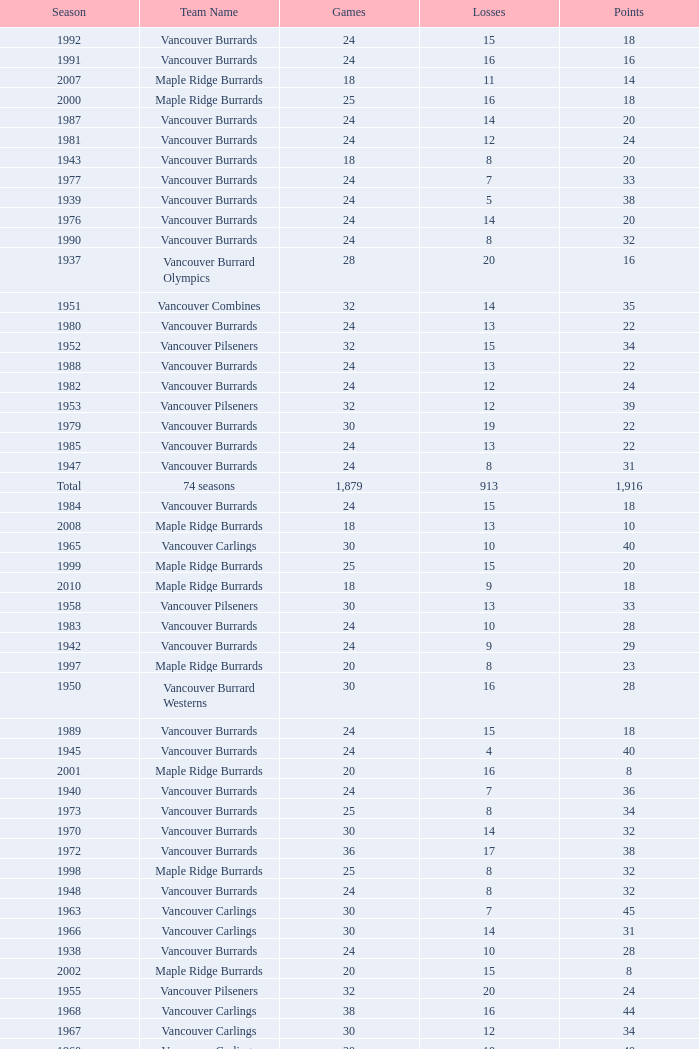What's the lowest number of points with fewer than 8 losses and fewer than 24 games for the vancouver burrards? 18.0. Write the full table. {'header': ['Season', 'Team Name', 'Games', 'Losses', 'Points'], 'rows': [['1992', 'Vancouver Burrards', '24', '15', '18'], ['1991', 'Vancouver Burrards', '24', '16', '16'], ['2007', 'Maple Ridge Burrards', '18', '11', '14'], ['2000', 'Maple Ridge Burrards', '25', '16', '18'], ['1987', 'Vancouver Burrards', '24', '14', '20'], ['1981', 'Vancouver Burrards', '24', '12', '24'], ['1943', 'Vancouver Burrards', '18', '8', '20'], ['1977', 'Vancouver Burrards', '24', '7', '33'], ['1939', 'Vancouver Burrards', '24', '5', '38'], ['1976', 'Vancouver Burrards', '24', '14', '20'], ['1990', 'Vancouver Burrards', '24', '8', '32'], ['1937', 'Vancouver Burrard Olympics', '28', '20', '16'], ['1951', 'Vancouver Combines', '32', '14', '35'], ['1980', 'Vancouver Burrards', '24', '13', '22'], ['1952', 'Vancouver Pilseners', '32', '15', '34'], ['1988', 'Vancouver Burrards', '24', '13', '22'], ['1982', 'Vancouver Burrards', '24', '12', '24'], ['1953', 'Vancouver Pilseners', '32', '12', '39'], ['1979', 'Vancouver Burrards', '30', '19', '22'], ['1985', 'Vancouver Burrards', '24', '13', '22'], ['1947', 'Vancouver Burrards', '24', '8', '31'], ['Total', '74 seasons', '1,879', '913', '1,916'], ['1984', 'Vancouver Burrards', '24', '15', '18'], ['2008', 'Maple Ridge Burrards', '18', '13', '10'], ['1965', 'Vancouver Carlings', '30', '10', '40'], ['1999', 'Maple Ridge Burrards', '25', '15', '20'], ['2010', 'Maple Ridge Burrards', '18', '9', '18'], ['1958', 'Vancouver Pilseners', '30', '13', '33'], ['1983', 'Vancouver Burrards', '24', '10', '28'], ['1942', 'Vancouver Burrards', '24', '9', '29'], ['1997', 'Maple Ridge Burrards', '20', '8', '23'], ['1950', 'Vancouver Burrard Westerns', '30', '16', '28'], ['1989', 'Vancouver Burrards', '24', '15', '18'], ['1945', 'Vancouver Burrards', '24', '4', '40'], ['2001', 'Maple Ridge Burrards', '20', '16', '8'], ['1940', 'Vancouver Burrards', '24', '7', '36'], ['1973', 'Vancouver Burrards', '25', '8', '34'], ['1970', 'Vancouver Burrards', '30', '14', '32'], ['1972', 'Vancouver Burrards', '36', '17', '38'], ['1998', 'Maple Ridge Burrards', '25', '8', '32'], ['1948', 'Vancouver Burrards', '24', '8', '32'], ['1963', 'Vancouver Carlings', '30', '7', '45'], ['1966', 'Vancouver Carlings', '30', '14', '31'], ['1938', 'Vancouver Burrards', '24', '10', '28'], ['2002', 'Maple Ridge Burrards', '20', '15', '8'], ['1955', 'Vancouver Pilseners', '32', '20', '24'], ['1968', 'Vancouver Carlings', '38', '16', '44'], ['1967', 'Vancouver Carlings', '30', '12', '34'], ['1960', 'Vancouver Carlings', '30', '10', '40'], ['1994', 'Surrey Burrards', '20', '12', '16'], ['2009', 'Maple Ridge Burrards', '18', '11', '14'], ['2006', 'Maple Ridge Burrards', '18', '11', '14'], ['1964', 'Vancouver Carlings', '32', '9', '46'], ['1961', 'Vancouver Carlings', '30', '9', '40'], ['1956', 'Vancouver Pilseners', '30', '13', '33'], ['1978', 'Vancouver Burrards', '24', '13', '22'], ['1993', 'Vancouver Burrards', '24', '20', '8'], ['1959', 'Vancouver Carlings', '30', '14', '31'], ['1974', 'Vancouver Burrards', '24', '13', '22'], ['2005', 'Maple Ridge Burrards', '18', '8', '19'], ['1941', 'Vancouver Burrards', '24', '7', '34'], ['1957', 'Vancouver Pilseners', '30', '20', '20'], ['2003', 'Maple Ridge Burrards', '20', '15', '10'], ['1971', 'Vancouver Burrards', '31', '18', '25'], ['1975', 'Vancouver Burrards', '24', '10', '28'], ['1949', 'Vancouver Burrards', '16', '7', '18'], ['1996', 'Maple Ridge Burrards', '20', '8', '23'], ['1954', 'Vancouver Pilseners', '32', '18', '28'], ['1962', 'Vancouver Carlings', '32', '6', '52'], ['1946', 'Vancouver Burrards', '24', '11', '25'], ['2004', 'Maple Ridge Burrards', '20', '12', '16'], ['1986', 'Vancouver Burrards', '24', '11', '26'], ['1969', 'Vancouver Carlings', '29', '20', '18'], ['1944', 'Vancouver Burrards', '24', '14', '20'], ['1995', 'Surrey Burrards', '25', '19', '11']]} 